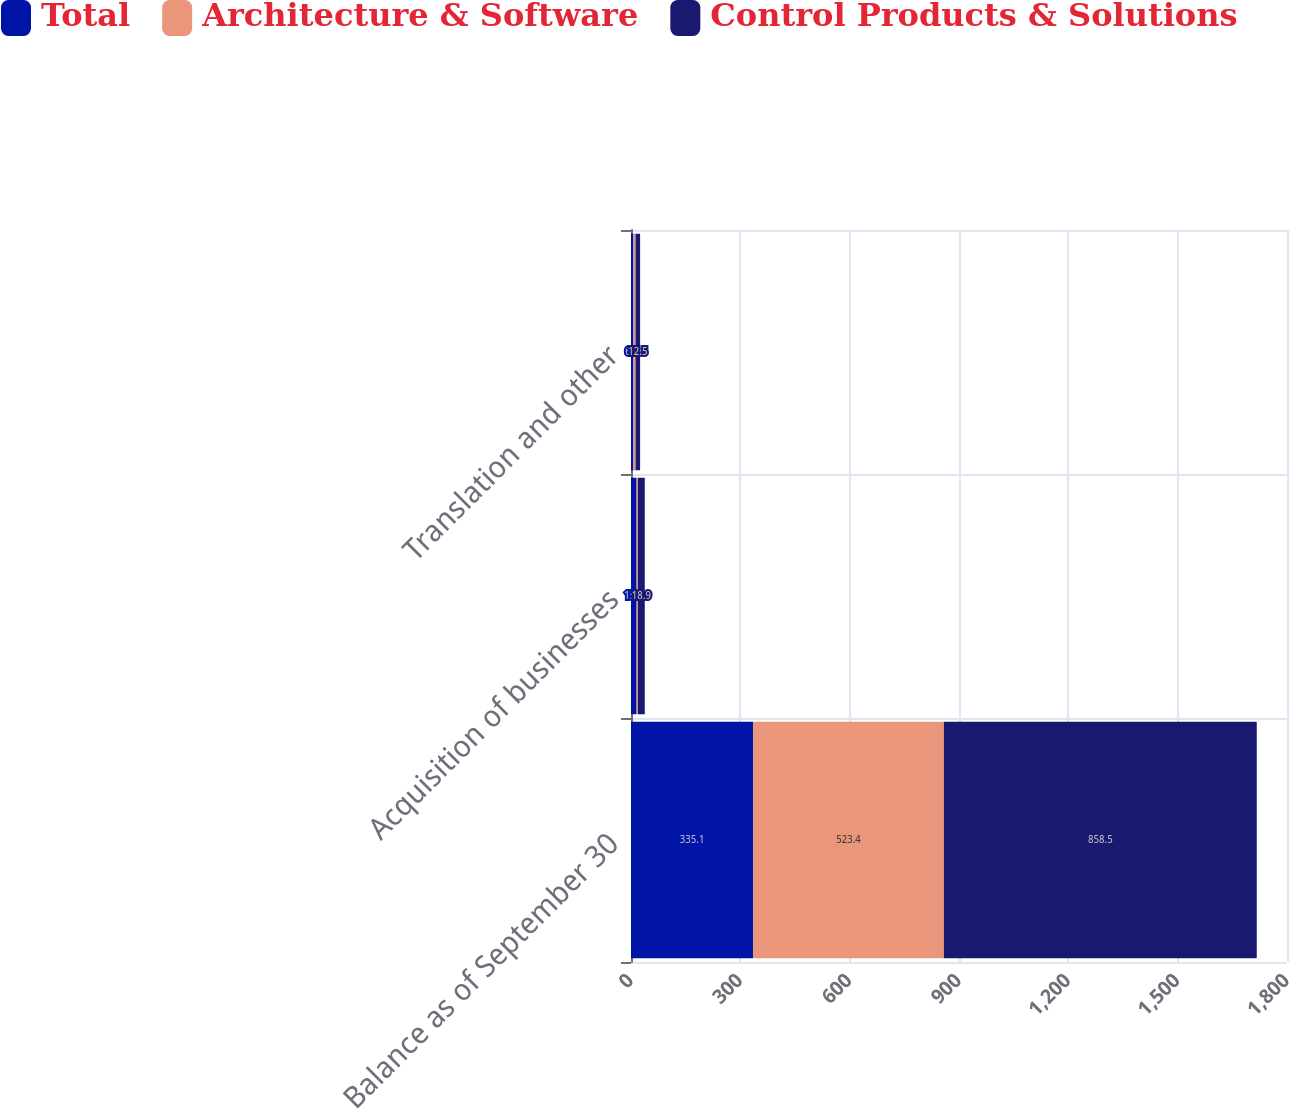Convert chart to OTSL. <chart><loc_0><loc_0><loc_500><loc_500><stacked_bar_chart><ecel><fcel>Balance as of September 30<fcel>Acquisition of businesses<fcel>Translation and other<nl><fcel>Total<fcel>335.1<fcel>15.4<fcel>6.7<nl><fcel>Architecture & Software<fcel>523.4<fcel>3.5<fcel>5.8<nl><fcel>Control Products & Solutions<fcel>858.5<fcel>18.9<fcel>12.5<nl></chart> 